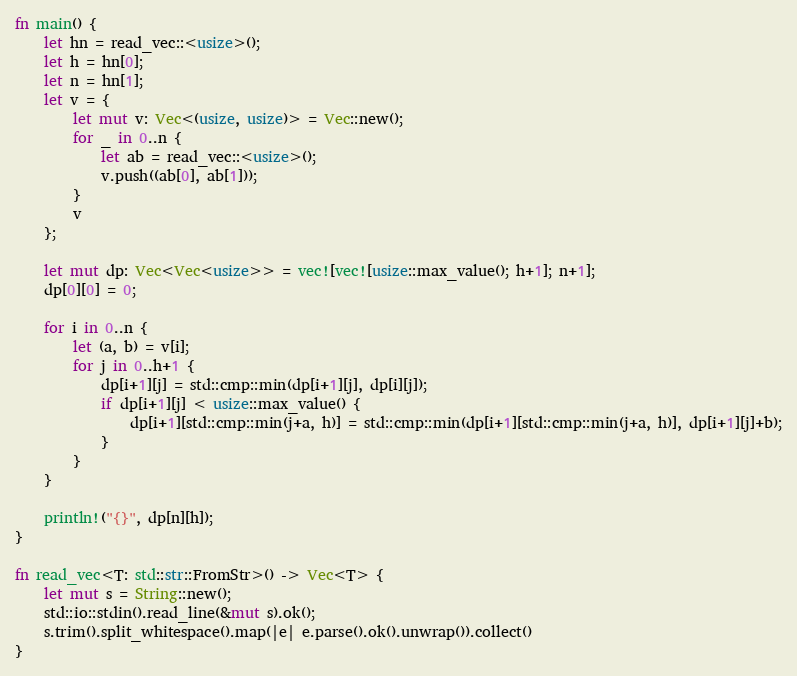Convert code to text. <code><loc_0><loc_0><loc_500><loc_500><_Rust_>fn main() {
    let hn = read_vec::<usize>();
    let h = hn[0];
    let n = hn[1];
    let v = {
        let mut v: Vec<(usize, usize)> = Vec::new();
        for _ in 0..n {
            let ab = read_vec::<usize>();
            v.push((ab[0], ab[1]));
        }
        v
    };

    let mut dp: Vec<Vec<usize>> = vec![vec![usize::max_value(); h+1]; n+1];
    dp[0][0] = 0;

    for i in 0..n {
        let (a, b) = v[i];
        for j in 0..h+1 {
            dp[i+1][j] = std::cmp::min(dp[i+1][j], dp[i][j]);
            if dp[i+1][j] < usize::max_value() {
                dp[i+1][std::cmp::min(j+a, h)] = std::cmp::min(dp[i+1][std::cmp::min(j+a, h)], dp[i+1][j]+b);
            }
        }
    }

    println!("{}", dp[n][h]);
}

fn read_vec<T: std::str::FromStr>() -> Vec<T> {
    let mut s = String::new();
    std::io::stdin().read_line(&mut s).ok();
    s.trim().split_whitespace().map(|e| e.parse().ok().unwrap()).collect()
}
</code> 